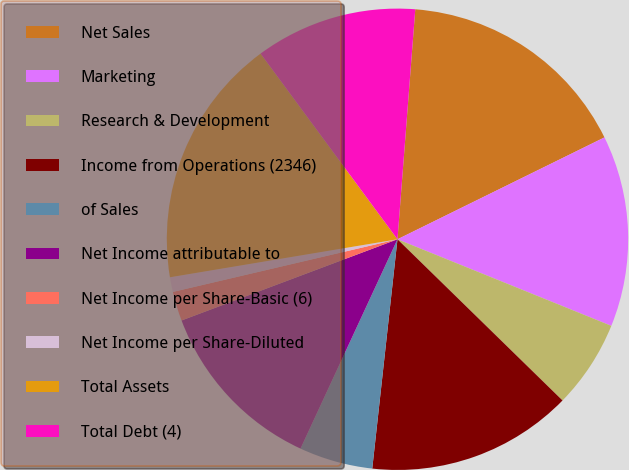Convert chart to OTSL. <chart><loc_0><loc_0><loc_500><loc_500><pie_chart><fcel>Net Sales<fcel>Marketing<fcel>Research & Development<fcel>Income from Operations (2346)<fcel>of Sales<fcel>Net Income attributable to<fcel>Net Income per Share-Basic (6)<fcel>Net Income per Share-Diluted<fcel>Total Assets<fcel>Total Debt (4)<nl><fcel>16.49%<fcel>13.4%<fcel>6.19%<fcel>14.43%<fcel>5.16%<fcel>12.37%<fcel>2.06%<fcel>1.03%<fcel>17.52%<fcel>11.34%<nl></chart> 